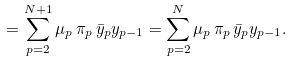<formula> <loc_0><loc_0><loc_500><loc_500>= \sum _ { p = 2 } ^ { N + 1 } \mu _ { p } \, \pi _ { p } \, \bar { y } _ { p } y _ { p - 1 } = \sum _ { p = 2 } ^ { N } \mu _ { p } \, \pi _ { p } \, \bar { y } _ { p } y _ { p - 1 } .</formula> 